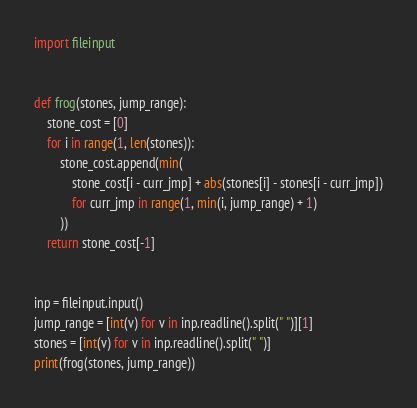Convert code to text. <code><loc_0><loc_0><loc_500><loc_500><_Python_>import fileinput


def frog(stones, jump_range):
    stone_cost = [0]
    for i in range(1, len(stones)):
        stone_cost.append(min(
            stone_cost[i - curr_jmp] + abs(stones[i] - stones[i - curr_jmp])
            for curr_jmp in range(1, min(i, jump_range) + 1)
        ))
    return stone_cost[-1]


inp = fileinput.input()
jump_range = [int(v) for v in inp.readline().split(" ")][1]
stones = [int(v) for v in inp.readline().split(" ")]
print(frog(stones, jump_range))</code> 